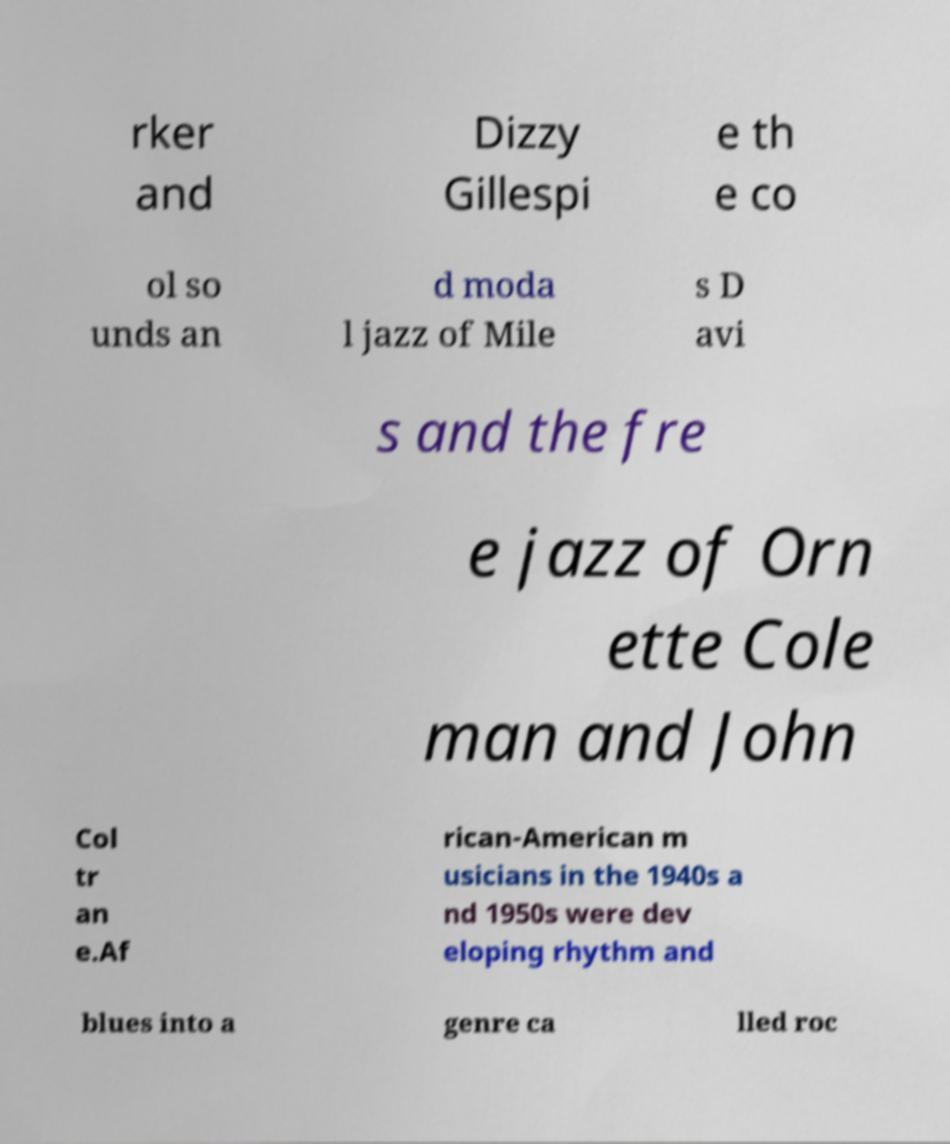Could you assist in decoding the text presented in this image and type it out clearly? rker and Dizzy Gillespi e th e co ol so unds an d moda l jazz of Mile s D avi s and the fre e jazz of Orn ette Cole man and John Col tr an e.Af rican-American m usicians in the 1940s a nd 1950s were dev eloping rhythm and blues into a genre ca lled roc 